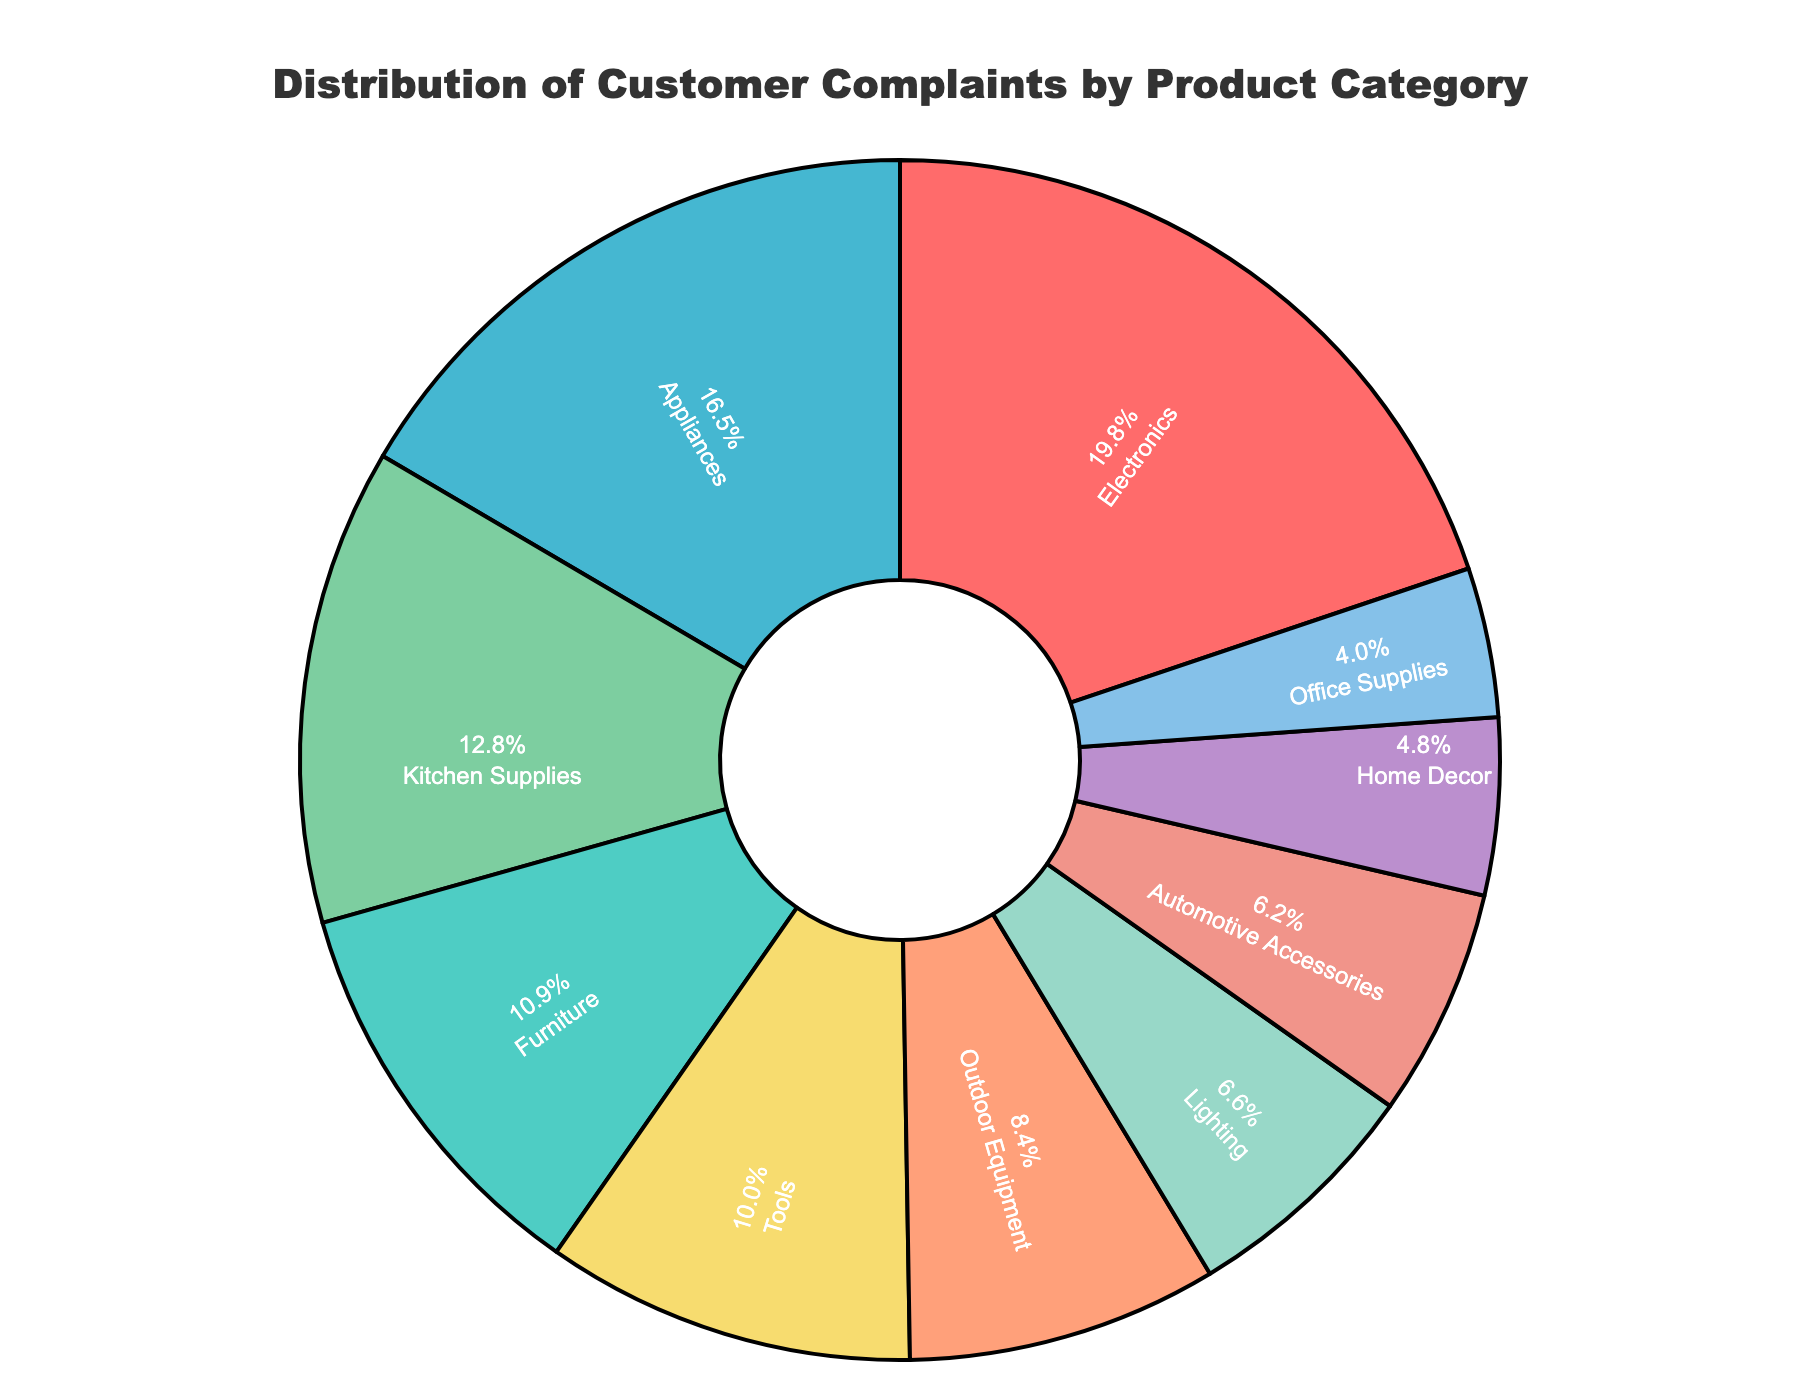What's the product category with the highest number of customer complaints? The largest segment in the pie chart represents the product category with the highest number of complaints. This segment is labeled 'Electronics'.
Answer: Electronics How many more complaints does the category with the highest complaints have compared to the category with the lowest complaints? The highest complaints are in 'Electronics' with 187 complaints, and the lowest are in 'Office Supplies' with 38 complaints. The difference is 187 - 38 = 149.
Answer: 149 What are the top three categories in terms of the number of complaints? The three largest segments in the pie chart represent the top three categories. They are labeled 'Electronics', 'Appliances', and 'Kitchen Supplies'.
Answer: Electronics, Appliances, Kitchen Supplies Which product category represents approximately one-quarter of all complaints? To find the category close to one-quarter, we look for a segment around 25%. The segment labeled 'Electronics' appears to be about 24.5%, making it close to one-quarter.
Answer: Electronics Are there more complaints about 'Tools' or 'Furniture'? By comparing the sizes of the segments, the 'Furniture' segment is larger than the 'Tools' segment.
Answer: Furniture What is the combined percentage of complaints for 'Automotive Accessories' and 'Home Decor'? Adding up the approximate percentages: 'Automotive Accessories' ~8% and 'Home Decor' ~6%, gives 8% + 6% = 14%.
Answer: 14% Which categories have less than 10% of the total complaints each? The segments for 'Outdoor Equipment', 'Lighting', 'Tools', 'Home Decor', 'Automotive Accessories', and 'Office Supplies' all appear to be less than 10%.
Answer: Outdoor Equipment, Lighting, Tools, Home Decor, Automotive Accessories, Office Supplies How does the number of complaints for 'Appliances' compare to 'Kitchen Supplies'? The segment sizes show that 'Appliances' have more complaints than 'Kitchen Supplies'.
Answer: Appliances What's the difference in the number of complaints between 'Furniture' and 'Tools'? 'Furniture' has 103 complaints and 'Tools' have 94 complaints. The difference is 103 - 94 = 9.
Answer: 9 What percentage of the total complaints does the 'Lighting' category represent? The pie chart shows 'Lighting' represents roughly 8% of the total complaints.
Answer: 8% 